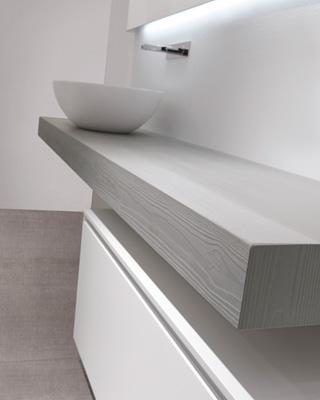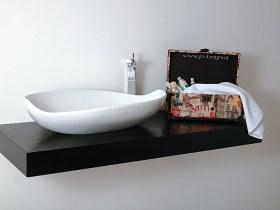The first image is the image on the left, the second image is the image on the right. Examine the images to the left and right. Is the description "One image shows a square white sink with a single upright chrome faucet fixture on it, atop a brown plank-type counter." accurate? Answer yes or no. No. The first image is the image on the left, the second image is the image on the right. For the images shown, is this caption "Both of the basins are rectangular shaped." true? Answer yes or no. No. 